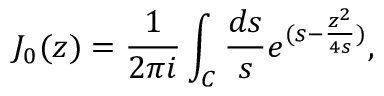Convert formula to latex. <formula><loc_0><loc_0><loc_500><loc_500>J _ { 0 } ( z ) = \frac { 1 } { 2 \pi i } \int _ { C } { \frac { d s } { s } } e ^ { ( s - { \frac { z ^ { 2 } } { 4 s } } ) } ,</formula> 